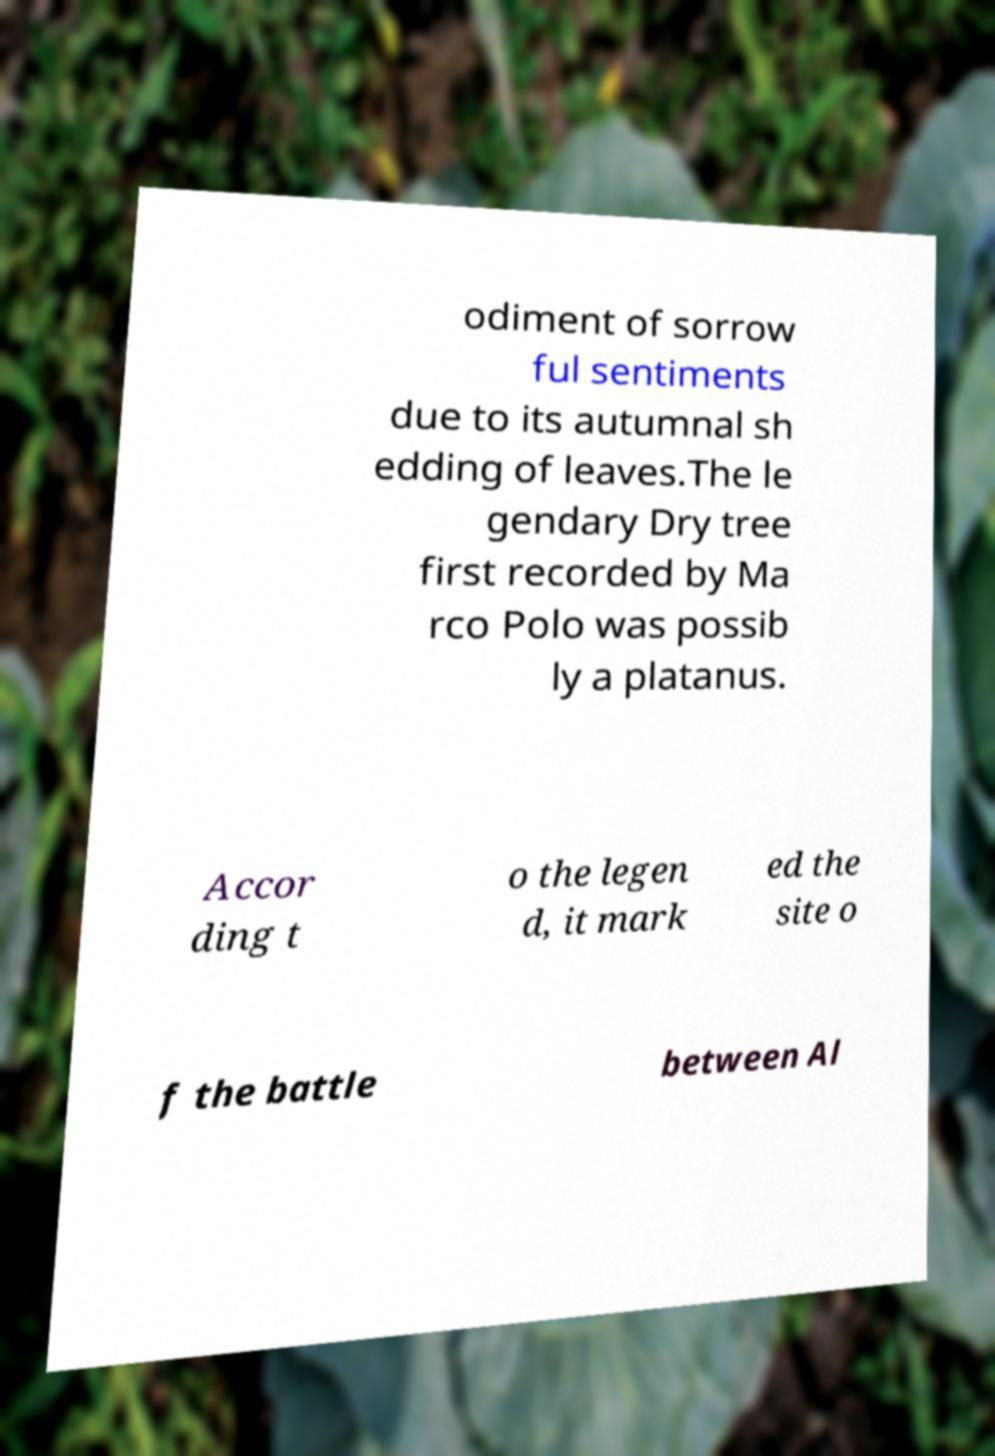Can you accurately transcribe the text from the provided image for me? odiment of sorrow ful sentiments due to its autumnal sh edding of leaves.The le gendary Dry tree first recorded by Ma rco Polo was possib ly a platanus. Accor ding t o the legen d, it mark ed the site o f the battle between Al 